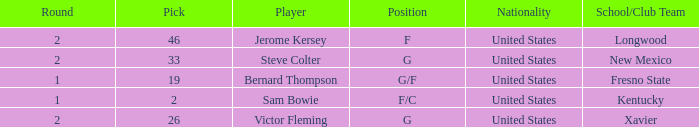What is Player, when Round is "2", and when School/Club Team is "Xavier"? Victor Fleming. 